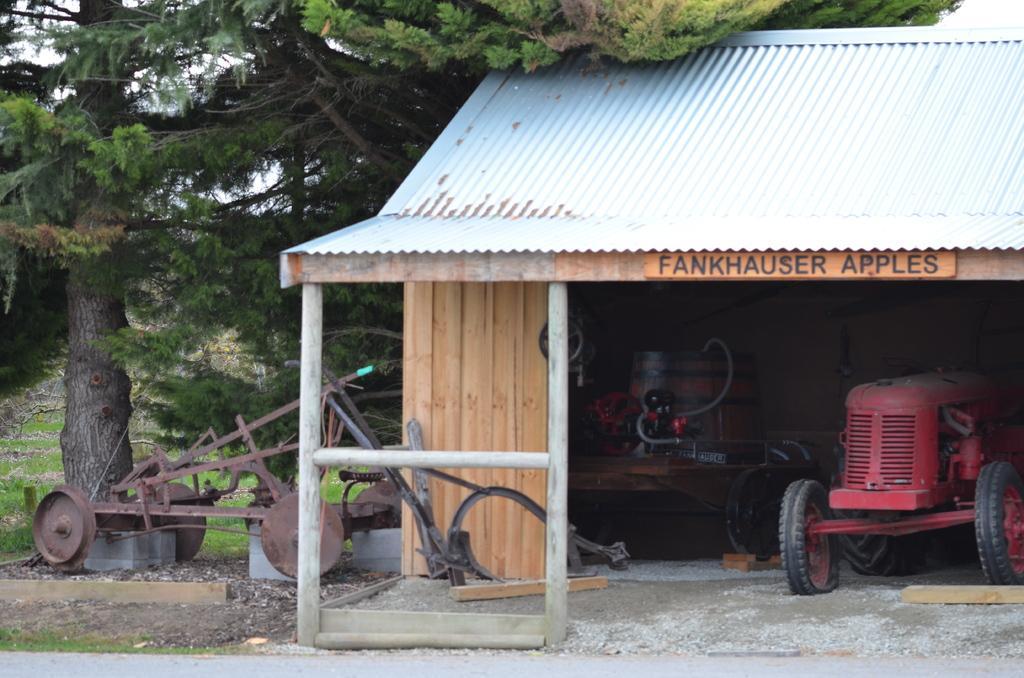In one or two sentences, can you explain what this image depicts? There is a tractor under the shed and other objects in the foreground area of the image, there are trees, grassland and the sky in the background. 